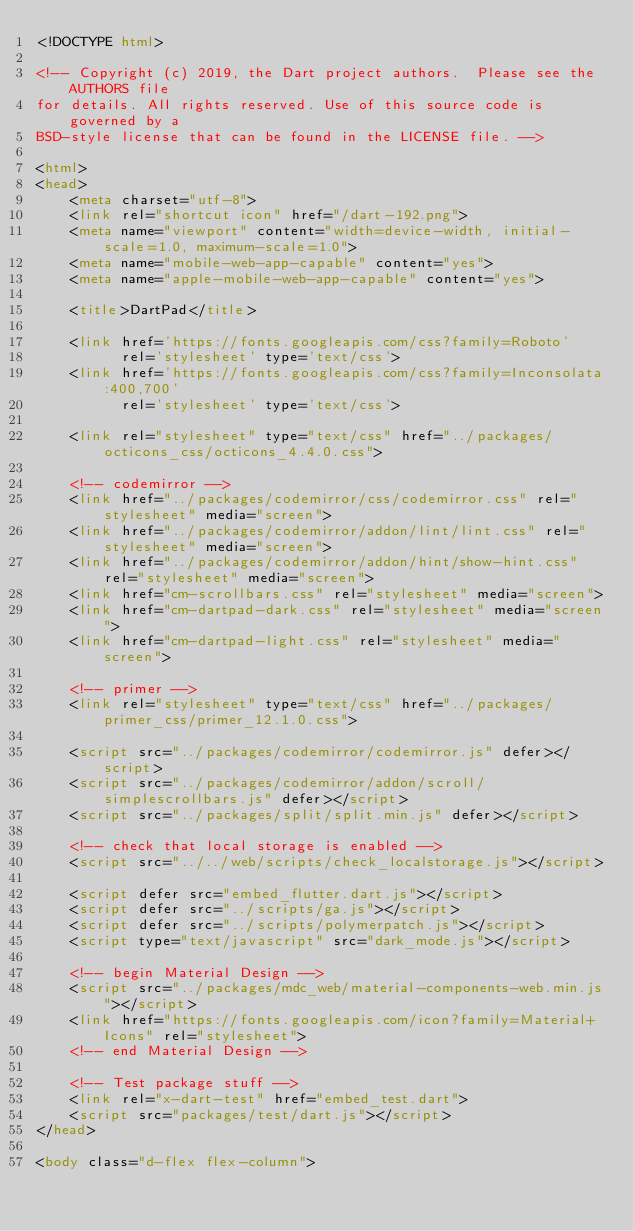<code> <loc_0><loc_0><loc_500><loc_500><_HTML_><!DOCTYPE html>

<!-- Copyright (c) 2019, the Dart project authors.  Please see the AUTHORS file
for details. All rights reserved. Use of this source code is governed by a
BSD-style license that can be found in the LICENSE file. -->

<html>
<head>
    <meta charset="utf-8">
    <link rel="shortcut icon" href="/dart-192.png">
    <meta name="viewport" content="width=device-width, initial-scale=1.0, maximum-scale=1.0">
    <meta name="mobile-web-app-capable" content="yes">
    <meta name="apple-mobile-web-app-capable" content="yes">

    <title>DartPad</title>

    <link href='https://fonts.googleapis.com/css?family=Roboto'
          rel='stylesheet' type='text/css'>
    <link href='https://fonts.googleapis.com/css?family=Inconsolata:400,700'
          rel='stylesheet' type='text/css'>

    <link rel="stylesheet" type="text/css" href="../packages/octicons_css/octicons_4.4.0.css">

    <!-- codemirror -->
    <link href="../packages/codemirror/css/codemirror.css" rel="stylesheet" media="screen">
    <link href="../packages/codemirror/addon/lint/lint.css" rel="stylesheet" media="screen">
    <link href="../packages/codemirror/addon/hint/show-hint.css" rel="stylesheet" media="screen">
    <link href="cm-scrollbars.css" rel="stylesheet" media="screen">
    <link href="cm-dartpad-dark.css" rel="stylesheet" media="screen">
    <link href="cm-dartpad-light.css" rel="stylesheet" media="screen">

    <!-- primer -->
    <link rel="stylesheet" type="text/css" href="../packages/primer_css/primer_12.1.0.css">

    <script src="../packages/codemirror/codemirror.js" defer></script>
    <script src="../packages/codemirror/addon/scroll/simplescrollbars.js" defer></script>
    <script src="../packages/split/split.min.js" defer></script>

    <!-- check that local storage is enabled -->
    <script src="../../web/scripts/check_localstorage.js"></script>

    <script defer src="embed_flutter.dart.js"></script>
    <script defer src="../scripts/ga.js"></script>
    <script defer src="../scripts/polymerpatch.js"></script>
    <script type="text/javascript" src="dark_mode.js"></script>

    <!-- begin Material Design -->
    <script src="../packages/mdc_web/material-components-web.min.js"></script>
    <link href="https://fonts.googleapis.com/icon?family=Material+Icons" rel="stylesheet">
    <!-- end Material Design -->

    <!-- Test package stuff -->
    <link rel="x-dart-test" href="embed_test.dart">
    <script src="packages/test/dart.js"></script>
</head>

<body class="d-flex flex-column"></code> 